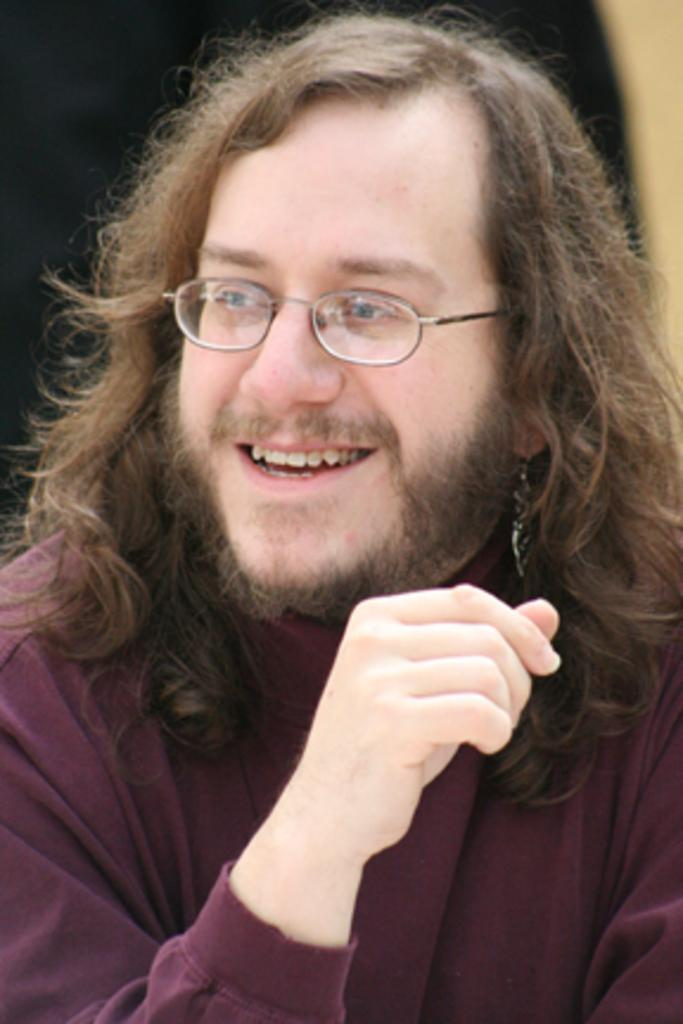Who is the main subject in the image? There is a man in the center of the image. What color is the background of the image? The background of the image is black in color. What type of plantation can be seen in the background of the image? There is no plantation present in the image; the background is black. 